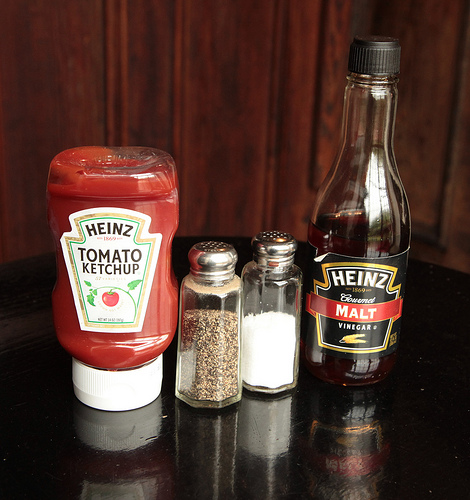<image>
Is the ketchup next to the vinegar? No. The ketchup is not positioned next to the vinegar. They are located in different areas of the scene. Is there a ketchup in front of the salt? No. The ketchup is not in front of the salt. The spatial positioning shows a different relationship between these objects. 